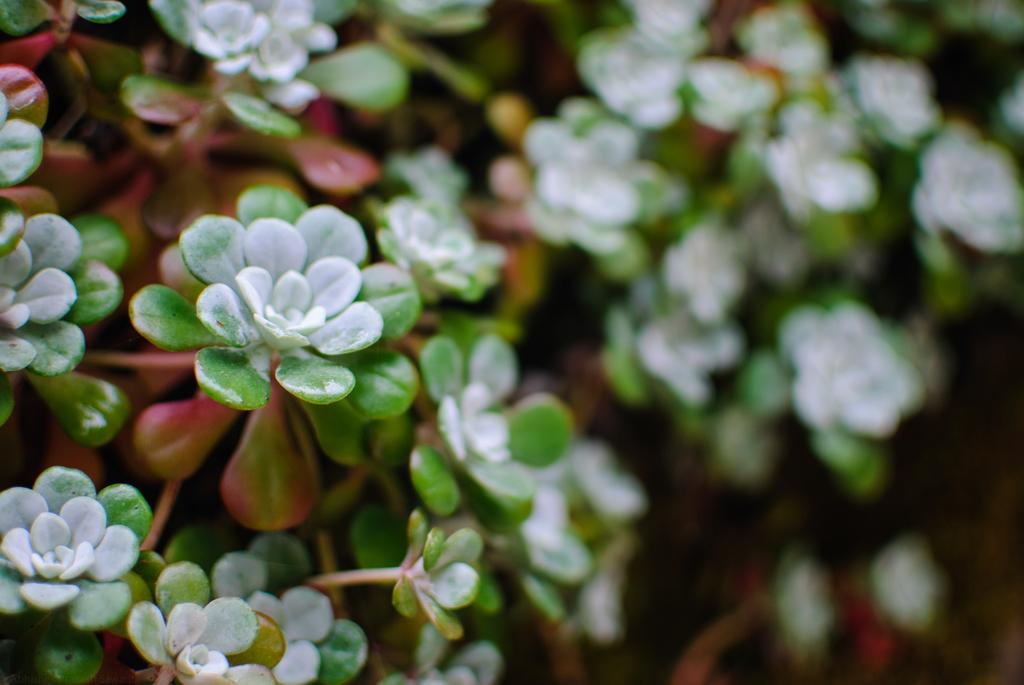What is present in the image? There is a plant in the image. Can you describe the appearance of the plant? The plant has white, green, and red leaves. What can be observed about the background of the image? The background of the image is blurred. Is there a fan blowing on the plant in the image? There is no fan present in the image, so it cannot be determined if it is blowing on the plant. 